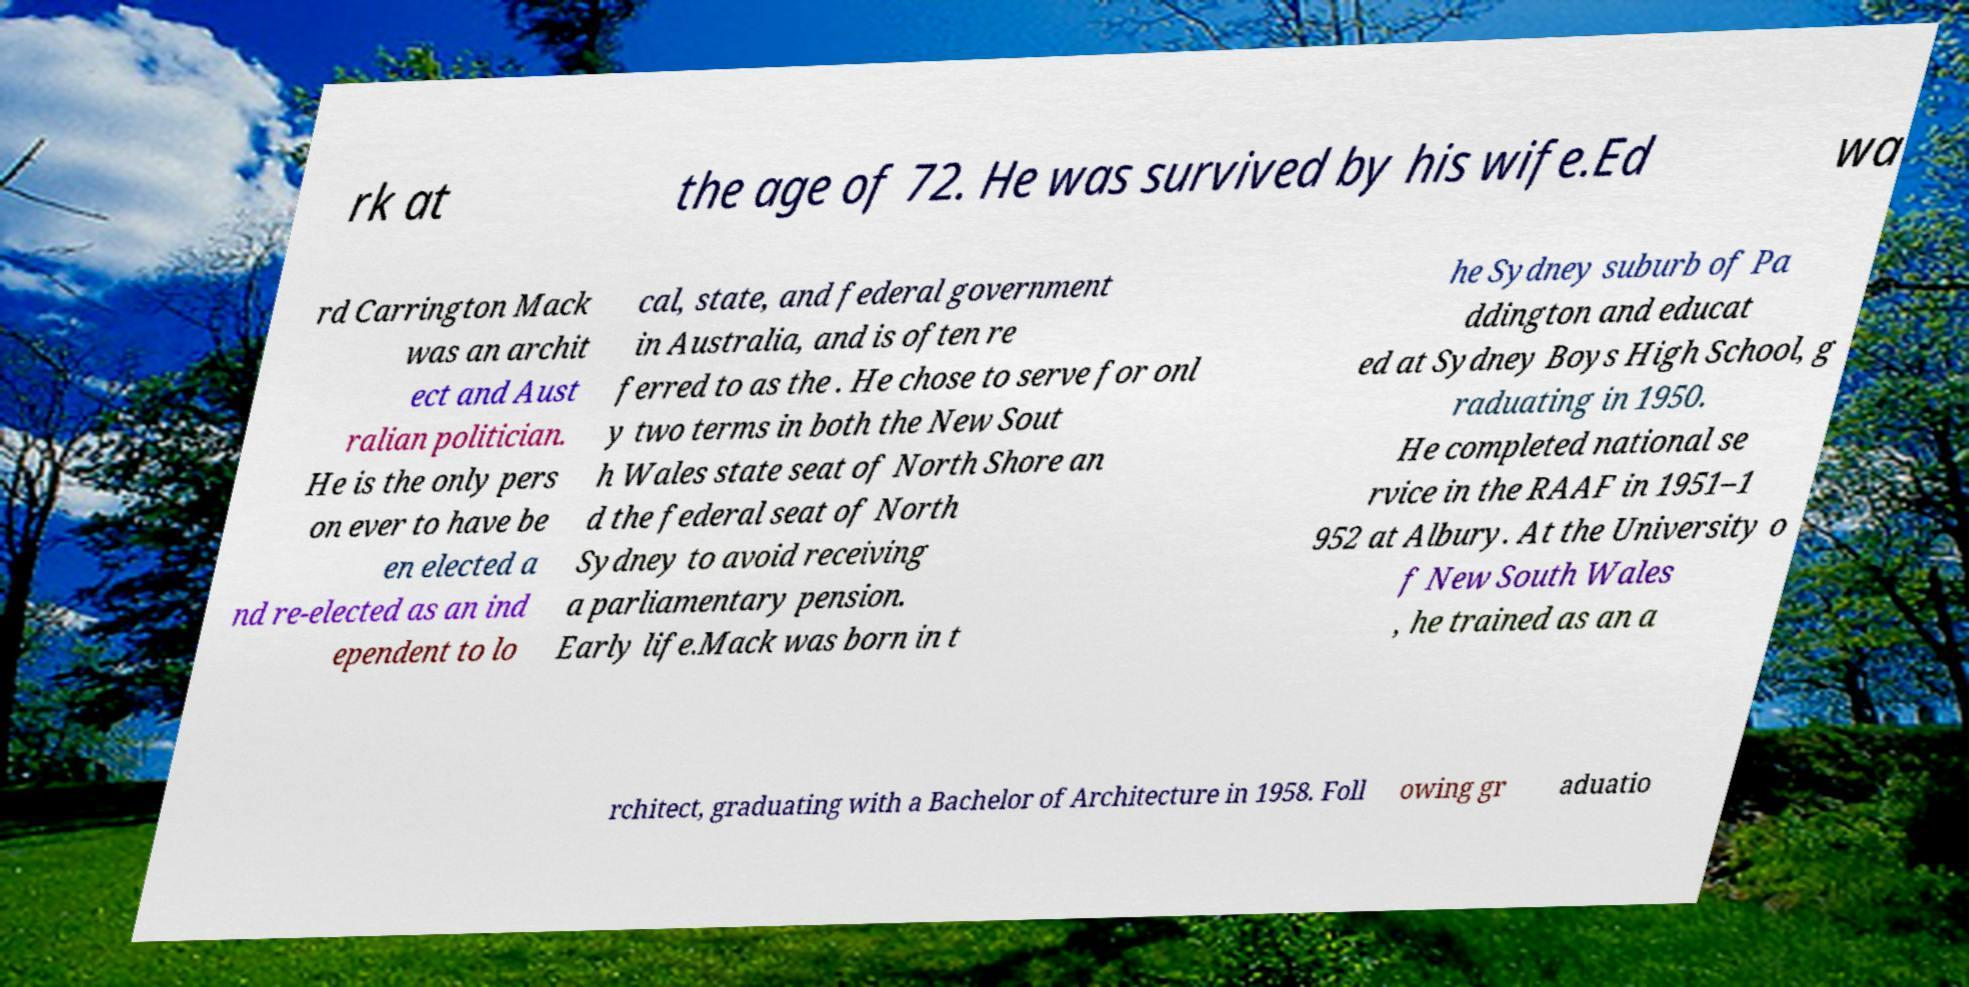Can you accurately transcribe the text from the provided image for me? rk at the age of 72. He was survived by his wife.Ed wa rd Carrington Mack was an archit ect and Aust ralian politician. He is the only pers on ever to have be en elected a nd re-elected as an ind ependent to lo cal, state, and federal government in Australia, and is often re ferred to as the . He chose to serve for onl y two terms in both the New Sout h Wales state seat of North Shore an d the federal seat of North Sydney to avoid receiving a parliamentary pension. Early life.Mack was born in t he Sydney suburb of Pa ddington and educat ed at Sydney Boys High School, g raduating in 1950. He completed national se rvice in the RAAF in 1951–1 952 at Albury. At the University o f New South Wales , he trained as an a rchitect, graduating with a Bachelor of Architecture in 1958. Foll owing gr aduatio 